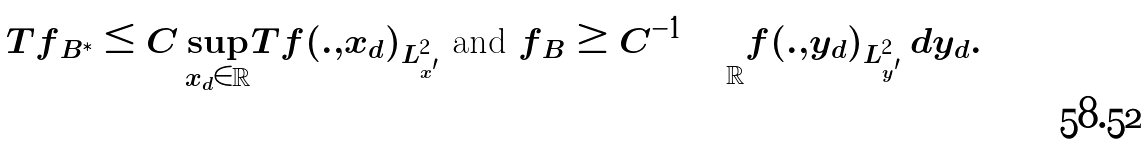<formula> <loc_0><loc_0><loc_500><loc_500>| | T f | | _ { B ^ { \ast } } \leq C \sup _ { x _ { d } \in \mathbb { R } } | | T f ( . , x _ { d } ) | | _ { L ^ { 2 } _ { x ^ { \prime } } } \text { and } | | f | | _ { B } \geq C ^ { - 1 } \int _ { \mathbb { R } } | | f ( . , y _ { d } ) | | _ { L ^ { 2 } _ { y ^ { \prime } } } \, d y _ { d } .</formula> 